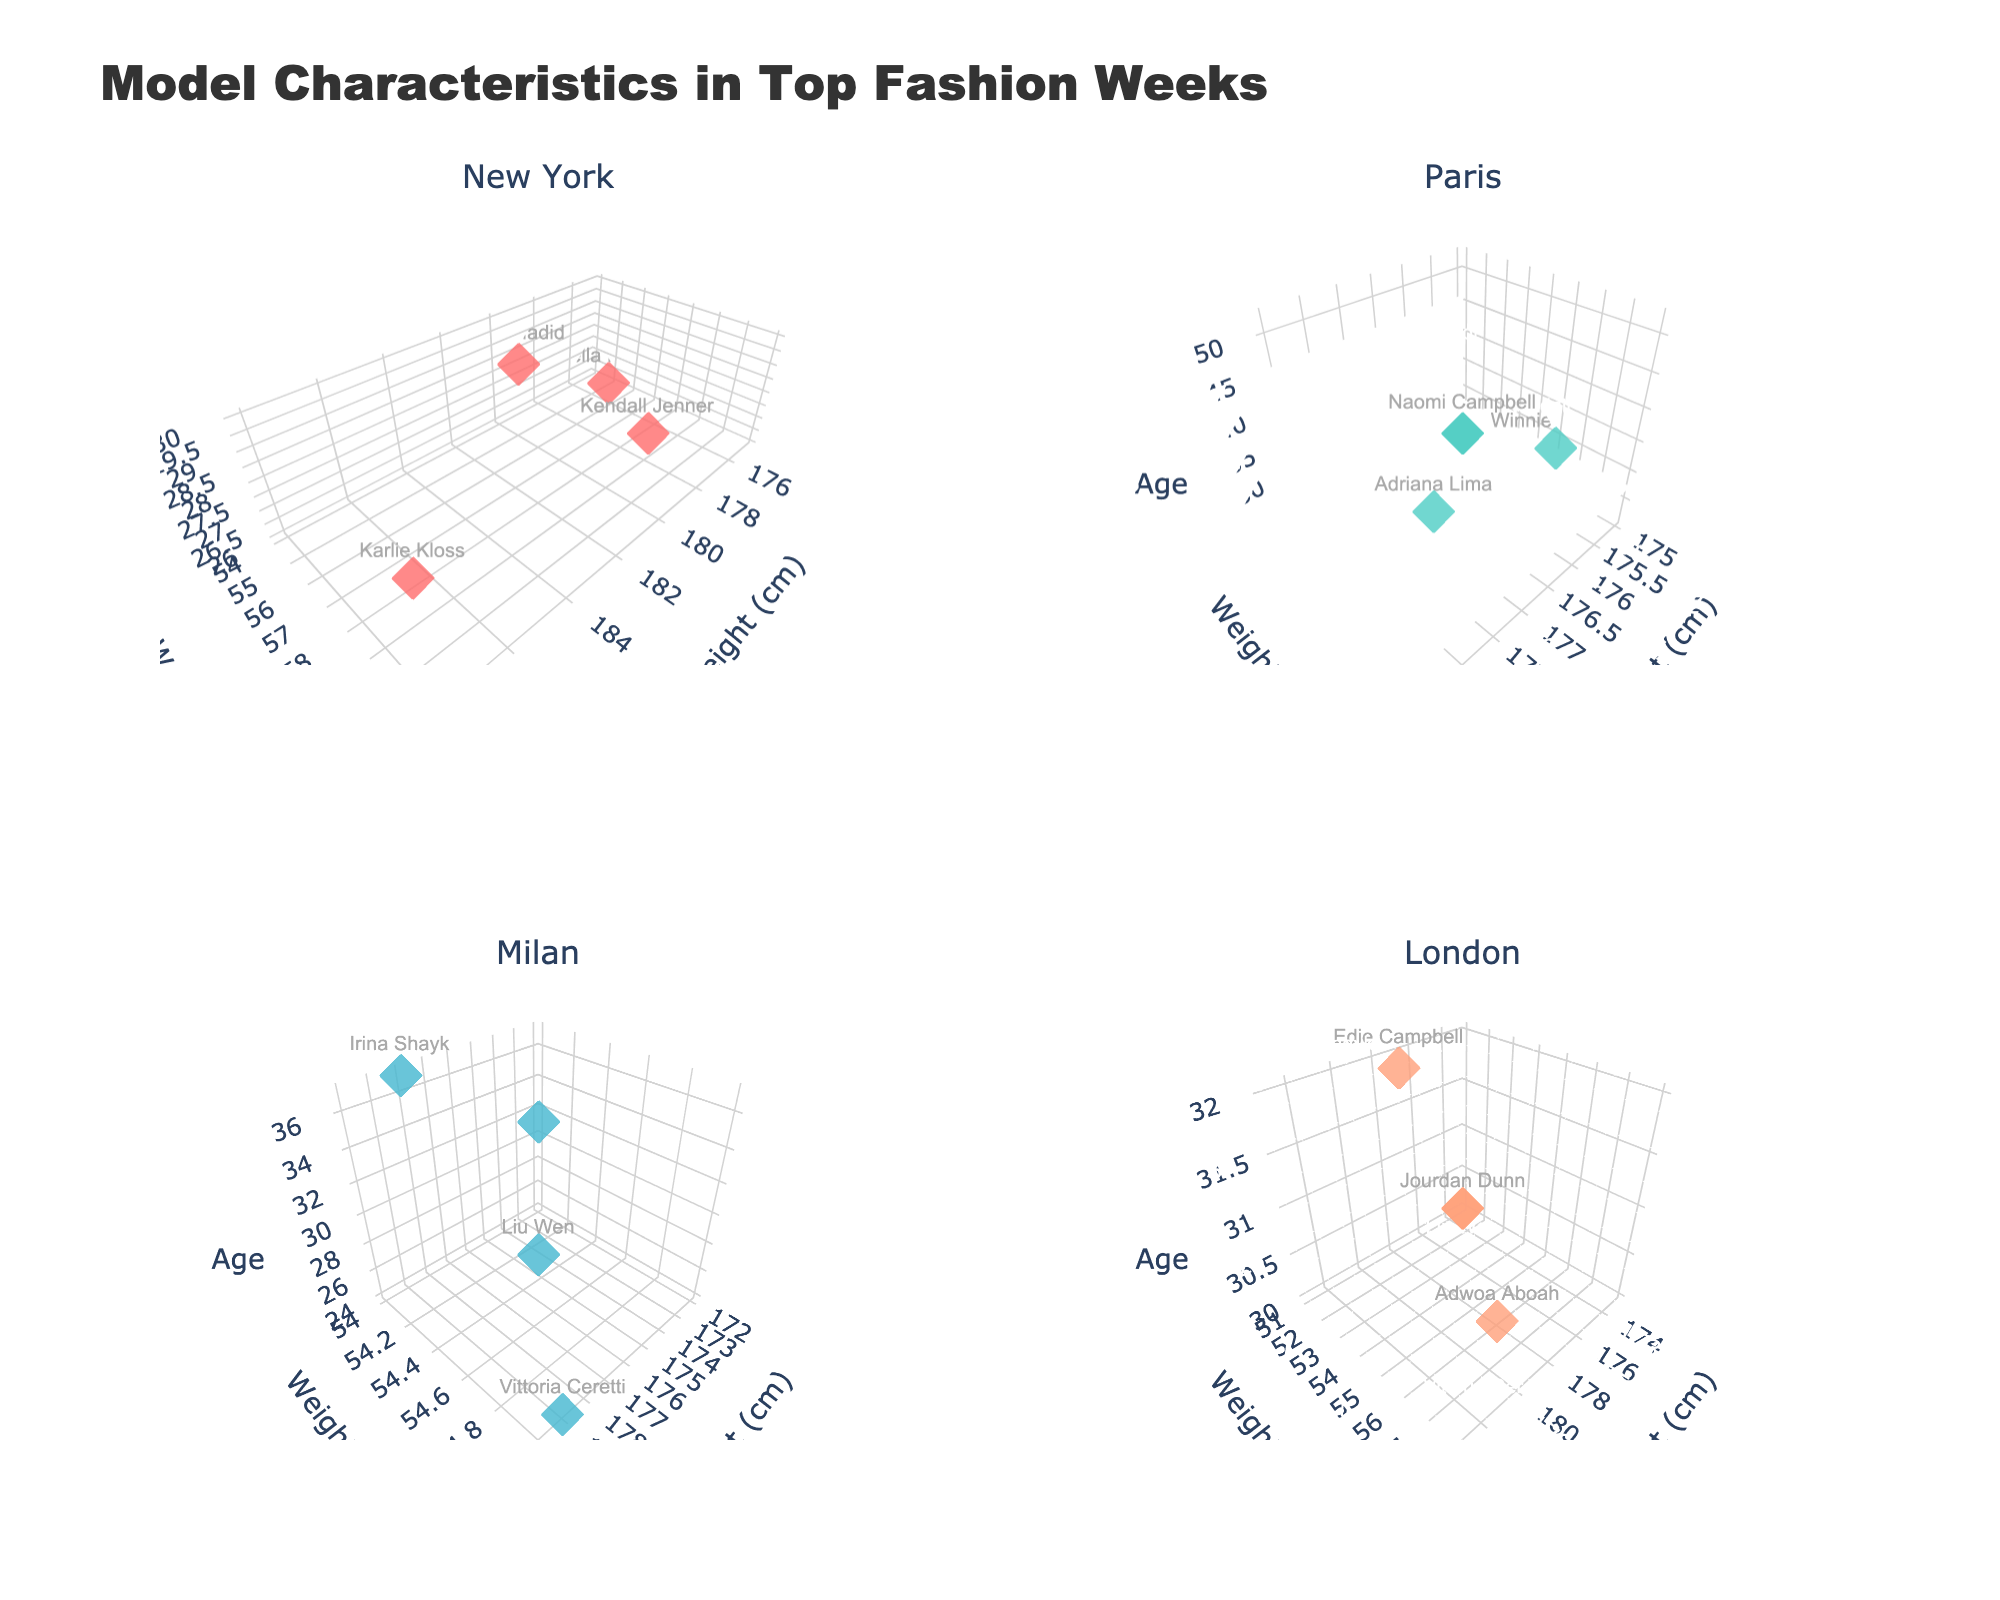What is the overall title of the figure? The title of the figure is written at the top center. It reads "Model Characteristics in Top Fashion Weeks".
Answer: Model Characteristics in Top Fashion Weeks What are the axes labels for each subplot? Each subplot has three-dimensional axes labeled "Height (cm)" for the x-axis, "Weight (kg)" for the y-axis, and "Age" for the z-axis.
Answer: Height (cm), Weight (kg), Age How many data points are there in the New York subplot? To determine the number of data points, count the individual points (markers) in the New York subplot. There are 4 data points corresponding to the models listed under New York.
Answer: 4 Which city has the oldest model showcased? By examining the z-axis (Age) in each subplot, we see that Naomi Campbell in the Paris subplot is 52 years old, which is the highest age among all plots.
Answer: Paris Are model weights generally higher in the Paris subplot compared to the Milan subplot? Compare the distribution of weights (y-axis) in the Paris and Milan subplots. The weights in Paris (ranging around mid-50s to 58 kg) are generally similar to those in Milan.
Answer: No What is the typical height range of models in the London subplot? Observing the x-axis (Height) in the London subplot, the heights range from 173 cm to 183 cm.
Answer: 173 cm to 183 cm Who is the shortest model in the Milan subplot, and what is her height? Check the Milan subplot and identify the shortest model on the x-axis. Sara Sampaio is the shortest with a height of 172 cm.
Answer: Sara Sampaio, 172 cm Comparing Kendall Jenner and Karlie Kloss in the New York subplot, who weighs more and by how much? Kendall Jenner weighs 59 kg, and Karlie Kloss weighs 61 kg. The difference is 61 kg - 59 kg = 2 kg.
Answer: Karlie Kloss by 2 kg Which subplot shows the model with the smallest weight, and what is that weight? Examine the y-axis (Weight) across all subplots. Kaia Gerber in the Paris subplot has the smallest weight of 50 kg.
Answer: Paris, 50 kg How does the average age of models in the London subplot compare to those in the New York subplot? Calculate the average age for each city. London: (30+32+30+32)/4 = 31 years, New York: (28+27+30+26)/4 = 27.75 years. London has a higher average age.
Answer: London models are older than New York models 